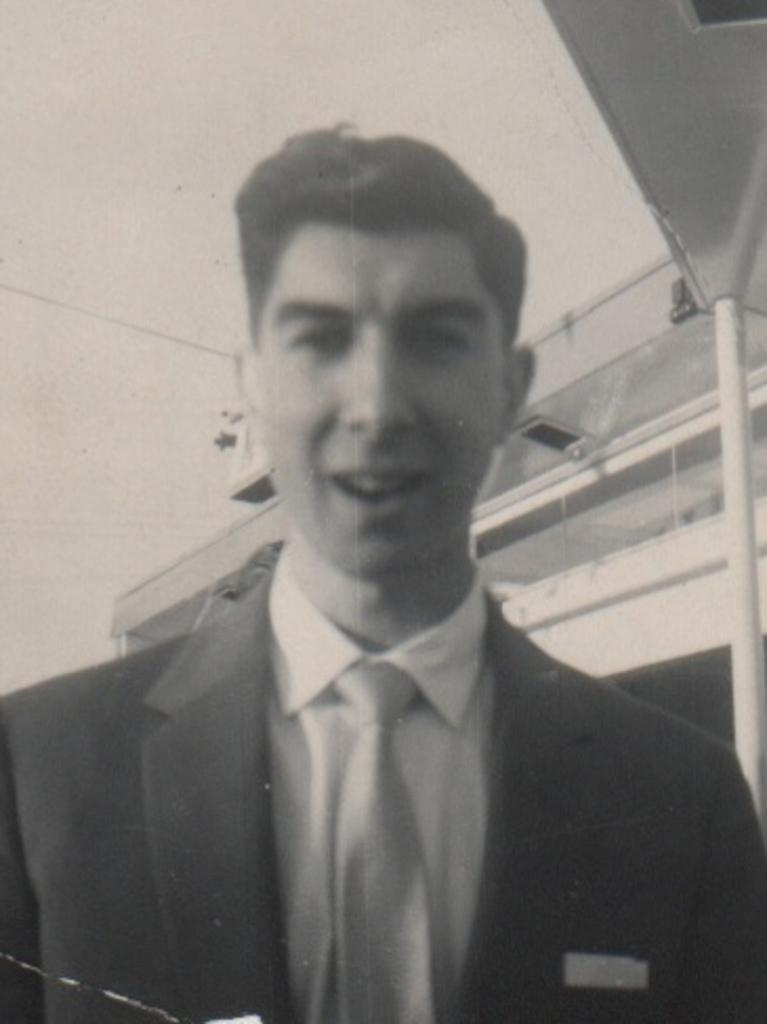What is the color scheme of the image? The image is black and white. Who or what can be seen in the image? There is a man in the image. What structure is present in the image? There is a building in the image. What part of the natural environment is visible in the image? The sky is visible in the background of the image. How many deer can be seen in the image? There are no deer present in the image. Are there any rabbits visible in the image? There are no rabbits present in the image. Can you see a zipper on the man's clothing in the image? The image is black and white, so it is difficult to determine if there is a zipper on the man's clothing. However, the presence of a zipper is not mentioned in the provided facts. 